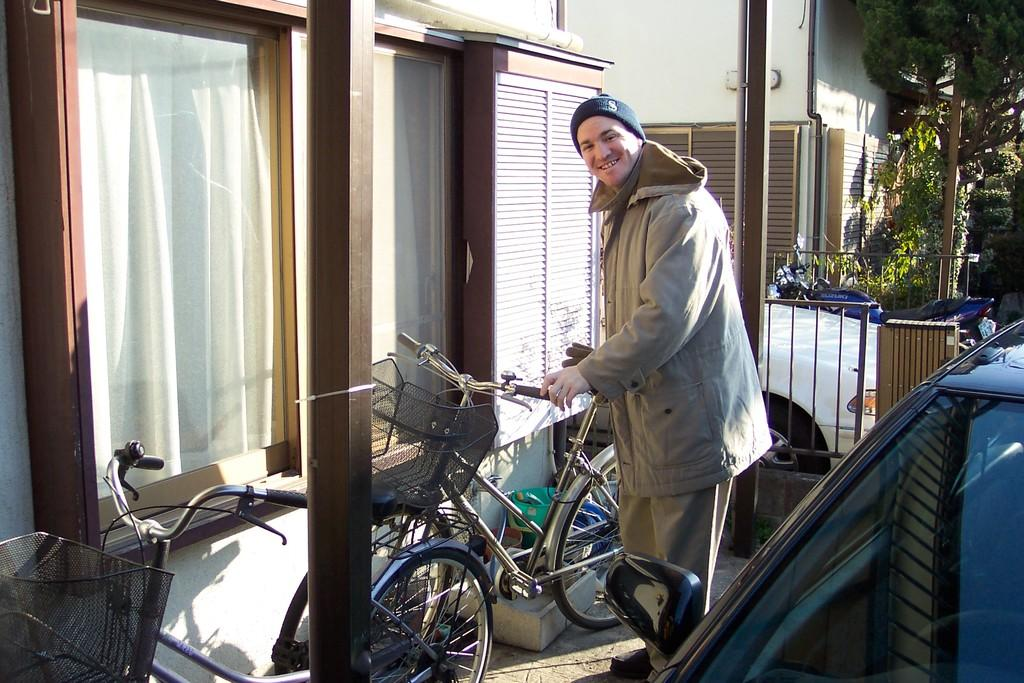What type of vehicles are in the image? There are bicycles in the image. Can you describe the person in the image? There is a man standing and smiling in the image. What is on the right side of the image? There is a car on the right side of the image. What can be seen in the background of the image? There are windows, trees, and a building visible in the background of the image. How many bicycles are in the image? There is one bike in the image. What type of jewel is the man wearing around his neck in the image? There is no jewel visible around the man's neck in the image. How many lizards can be seen climbing on the trees in the background of the image? There are no lizards present in the image; only trees and a building are visible in the background. 